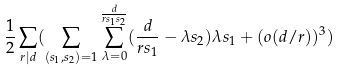Convert formula to latex. <formula><loc_0><loc_0><loc_500><loc_500>\frac { 1 } { 2 } \sum _ { r | d } ( \sum _ { ( s _ { 1 } , s _ { 2 } ) = 1 } \sum _ { \lambda = 0 } ^ { \frac { d } { r s _ { 1 } s _ { 2 } } } ( \frac { d } { r s _ { 1 } } - \lambda s _ { 2 } ) \lambda s _ { 1 } + ( o ( d / r ) ) ^ { 3 } )</formula> 